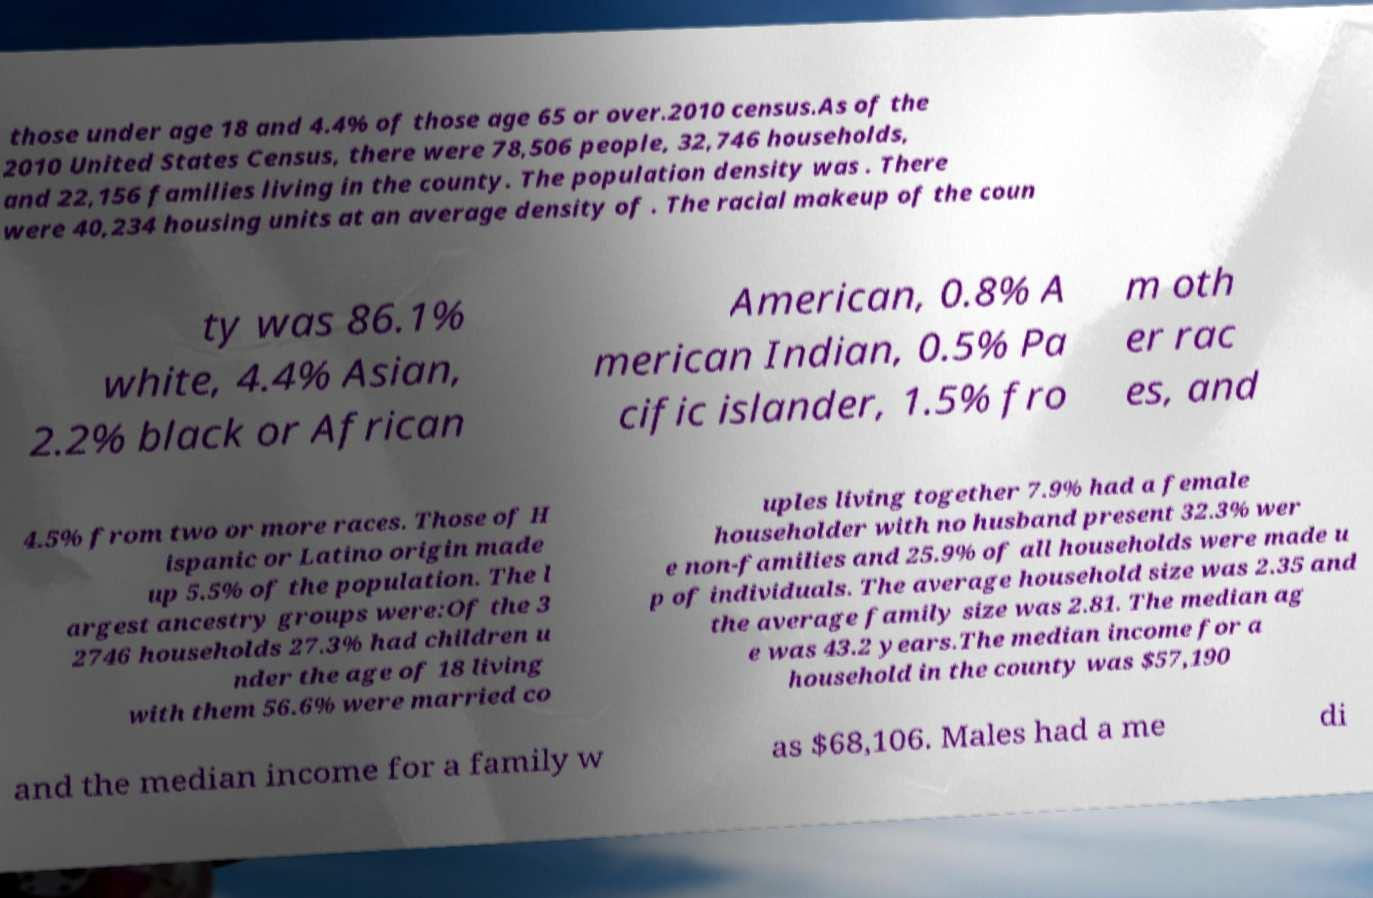Please read and relay the text visible in this image. What does it say? those under age 18 and 4.4% of those age 65 or over.2010 census.As of the 2010 United States Census, there were 78,506 people, 32,746 households, and 22,156 families living in the county. The population density was . There were 40,234 housing units at an average density of . The racial makeup of the coun ty was 86.1% white, 4.4% Asian, 2.2% black or African American, 0.8% A merican Indian, 0.5% Pa cific islander, 1.5% fro m oth er rac es, and 4.5% from two or more races. Those of H ispanic or Latino origin made up 5.5% of the population. The l argest ancestry groups were:Of the 3 2746 households 27.3% had children u nder the age of 18 living with them 56.6% were married co uples living together 7.9% had a female householder with no husband present 32.3% wer e non-families and 25.9% of all households were made u p of individuals. The average household size was 2.35 and the average family size was 2.81. The median ag e was 43.2 years.The median income for a household in the county was $57,190 and the median income for a family w as $68,106. Males had a me di 